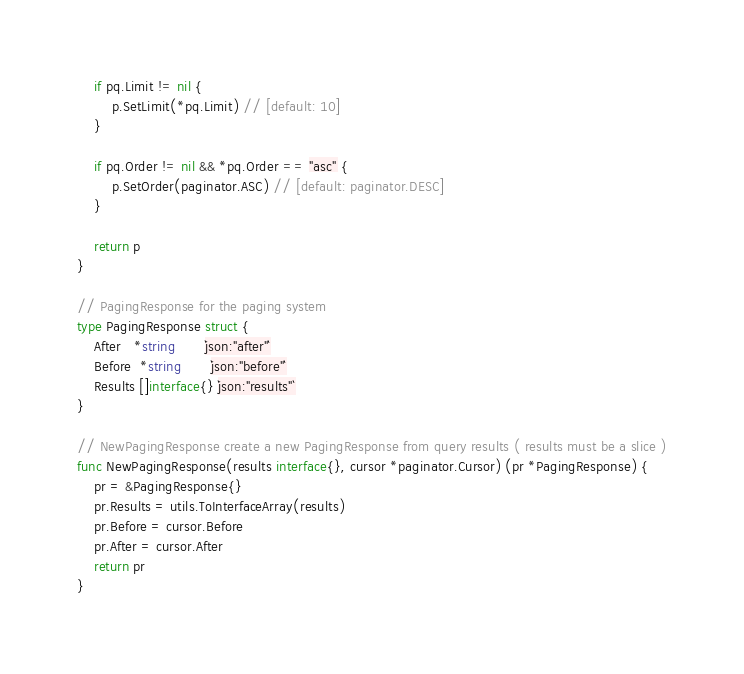<code> <loc_0><loc_0><loc_500><loc_500><_Go_>	if pq.Limit != nil {
		p.SetLimit(*pq.Limit) // [default: 10]
	}

	if pq.Order != nil && *pq.Order == "asc" {
		p.SetOrder(paginator.ASC) // [default: paginator.DESC]
	}

	return p
}

// PagingResponse for the paging system
type PagingResponse struct {
	After   *string       `json:"after"`
	Before  *string       `json:"before"`
	Results []interface{} `json:"results"`
}

// NewPagingResponse create a new PagingResponse from query results ( results must be a slice )
func NewPagingResponse(results interface{}, cursor *paginator.Cursor) (pr *PagingResponse) {
	pr = &PagingResponse{}
	pr.Results = utils.ToInterfaceArray(results)
	pr.Before = cursor.Before
	pr.After = cursor.After
	return pr
}
</code> 